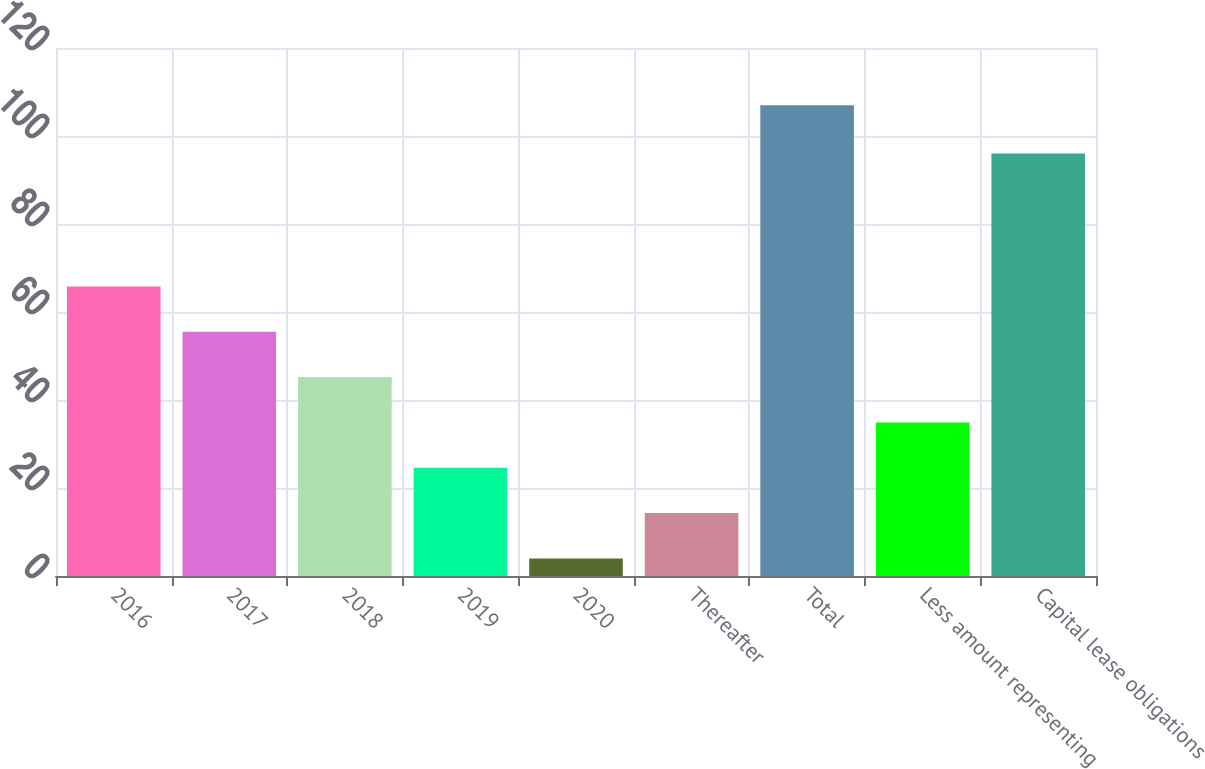<chart> <loc_0><loc_0><loc_500><loc_500><bar_chart><fcel>2016<fcel>2017<fcel>2018<fcel>2019<fcel>2020<fcel>Thereafter<fcel>Total<fcel>Less amount representing<fcel>Capital lease obligations<nl><fcel>65.8<fcel>55.5<fcel>45.2<fcel>24.6<fcel>4<fcel>14.3<fcel>107<fcel>34.9<fcel>96<nl></chart> 